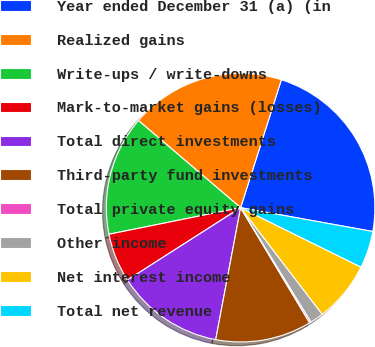<chart> <loc_0><loc_0><loc_500><loc_500><pie_chart><fcel>Year ended December 31 (a) (in<fcel>Realized gains<fcel>Write-ups / write-downs<fcel>Mark-to-market gains (losses)<fcel>Total direct investments<fcel>Third-party fund investments<fcel>Total private equity gains<fcel>Other income<fcel>Net interest income<fcel>Total net revenue<nl><fcel>22.93%<fcel>18.67%<fcel>14.41%<fcel>5.88%<fcel>12.98%<fcel>11.56%<fcel>0.19%<fcel>1.62%<fcel>7.3%<fcel>4.46%<nl></chart> 